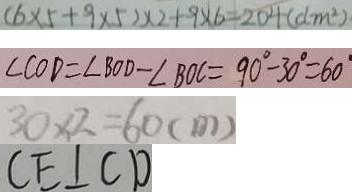<formula> <loc_0><loc_0><loc_500><loc_500>( 6 \times 5 + 9 \times 5 ) \times 2 + 9 \times 6 = 2 0 4 ( d m ^ { 2 } ) 
 \angle C O D = \angle B O D - \angle B O C = 9 0 ^ { \circ } - 3 0 ^ { \circ } = 6 0 ^ { \circ } 
 3 0 \times 2 = 6 0 ( m ) 
 C E \bot C D</formula> 